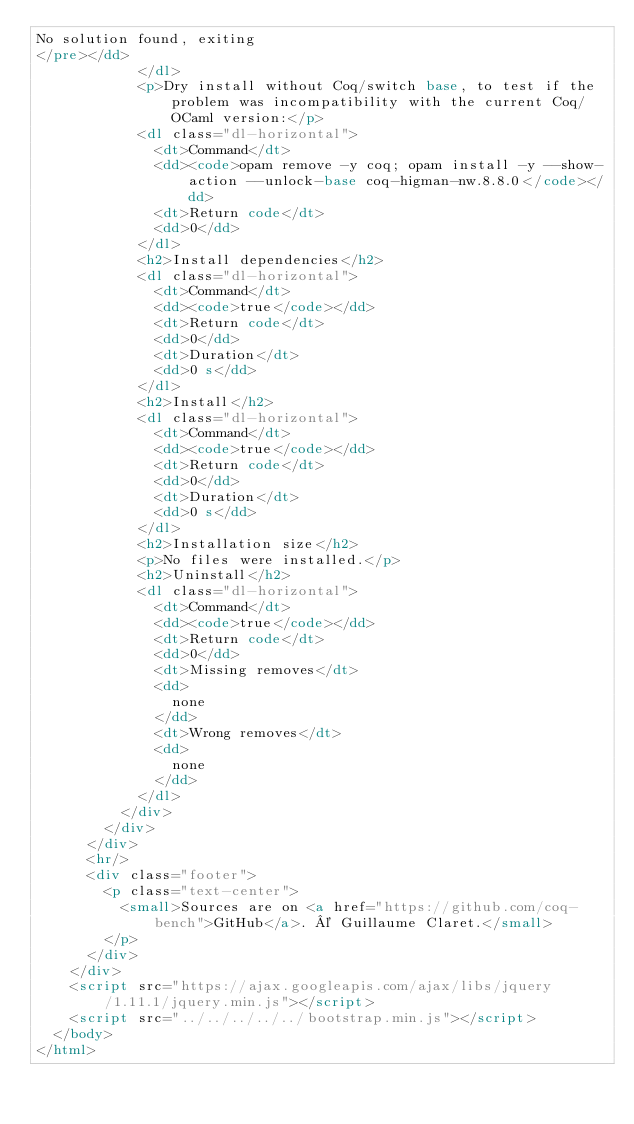<code> <loc_0><loc_0><loc_500><loc_500><_HTML_>No solution found, exiting
</pre></dd>
            </dl>
            <p>Dry install without Coq/switch base, to test if the problem was incompatibility with the current Coq/OCaml version:</p>
            <dl class="dl-horizontal">
              <dt>Command</dt>
              <dd><code>opam remove -y coq; opam install -y --show-action --unlock-base coq-higman-nw.8.8.0</code></dd>
              <dt>Return code</dt>
              <dd>0</dd>
            </dl>
            <h2>Install dependencies</h2>
            <dl class="dl-horizontal">
              <dt>Command</dt>
              <dd><code>true</code></dd>
              <dt>Return code</dt>
              <dd>0</dd>
              <dt>Duration</dt>
              <dd>0 s</dd>
            </dl>
            <h2>Install</h2>
            <dl class="dl-horizontal">
              <dt>Command</dt>
              <dd><code>true</code></dd>
              <dt>Return code</dt>
              <dd>0</dd>
              <dt>Duration</dt>
              <dd>0 s</dd>
            </dl>
            <h2>Installation size</h2>
            <p>No files were installed.</p>
            <h2>Uninstall</h2>
            <dl class="dl-horizontal">
              <dt>Command</dt>
              <dd><code>true</code></dd>
              <dt>Return code</dt>
              <dd>0</dd>
              <dt>Missing removes</dt>
              <dd>
                none
              </dd>
              <dt>Wrong removes</dt>
              <dd>
                none
              </dd>
            </dl>
          </div>
        </div>
      </div>
      <hr/>
      <div class="footer">
        <p class="text-center">
          <small>Sources are on <a href="https://github.com/coq-bench">GitHub</a>. © Guillaume Claret.</small>
        </p>
      </div>
    </div>
    <script src="https://ajax.googleapis.com/ajax/libs/jquery/1.11.1/jquery.min.js"></script>
    <script src="../../../../../bootstrap.min.js"></script>
  </body>
</html>
</code> 